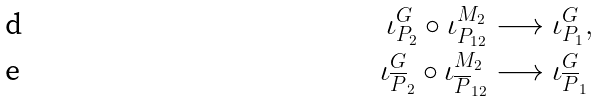<formula> <loc_0><loc_0><loc_500><loc_500>\iota _ { P _ { 2 } } ^ { G } \circ \iota _ { P _ { 1 2 } } ^ { M _ { 2 } } & \longrightarrow \iota _ { P _ { 1 } } ^ { G } , \\ \iota _ { \overline { P } _ { 2 } } ^ { G } \circ \iota _ { \overline { P } _ { 1 2 } } ^ { M _ { 2 } } & \longrightarrow \iota _ { \overline { P } _ { 1 } } ^ { G }</formula> 